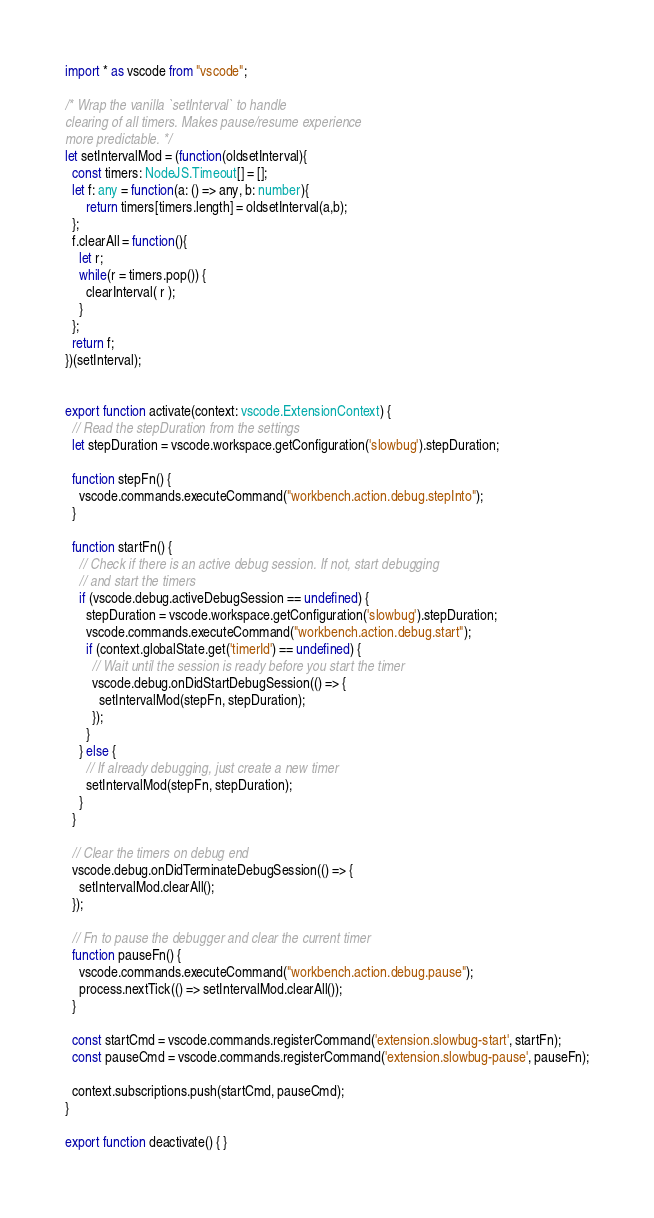Convert code to text. <code><loc_0><loc_0><loc_500><loc_500><_TypeScript_>import * as vscode from "vscode";

/* Wrap the vanilla `setInterval` to handle
clearing of all timers. Makes pause/resume experience
more predictable. */
let setIntervalMod = (function(oldsetInterval){
  const timers: NodeJS.Timeout[] = [];
  let f: any = function(a: () => any, b: number){
      return timers[timers.length] = oldsetInterval(a,b);
  };
  f.clearAll = function(){
    let r;
    while(r = timers.pop()) { 
      clearInterval( r );
    }       
  };
  return f;    
})(setInterval);


export function activate(context: vscode.ExtensionContext) {
  // Read the stepDuration from the settings
  let stepDuration = vscode.workspace.getConfiguration('slowbug').stepDuration;

  function stepFn() {
    vscode.commands.executeCommand("workbench.action.debug.stepInto");
  }

  function startFn() {
    // Check if there is an active debug session. If not, start debugging
    // and start the timers
    if (vscode.debug.activeDebugSession == undefined) {
      stepDuration = vscode.workspace.getConfiguration('slowbug').stepDuration;
      vscode.commands.executeCommand("workbench.action.debug.start");
      if (context.globalState.get('timerId') == undefined) {
        // Wait until the session is ready before you start the timer
        vscode.debug.onDidStartDebugSession(() => {
          setIntervalMod(stepFn, stepDuration);
        });
      }
    } else {
      // If already debugging, just create a new timer
      setIntervalMod(stepFn, stepDuration);
    }
  }

  // Clear the timers on debug end
  vscode.debug.onDidTerminateDebugSession(() => {
    setIntervalMod.clearAll();
  });

  // Fn to pause the debugger and clear the current timer
  function pauseFn() {
    vscode.commands.executeCommand("workbench.action.debug.pause");
    process.nextTick(() => setIntervalMod.clearAll());
  }

  const startCmd = vscode.commands.registerCommand('extension.slowbug-start', startFn);
  const pauseCmd = vscode.commands.registerCommand('extension.slowbug-pause', pauseFn);

  context.subscriptions.push(startCmd, pauseCmd);
}

export function deactivate() { }</code> 